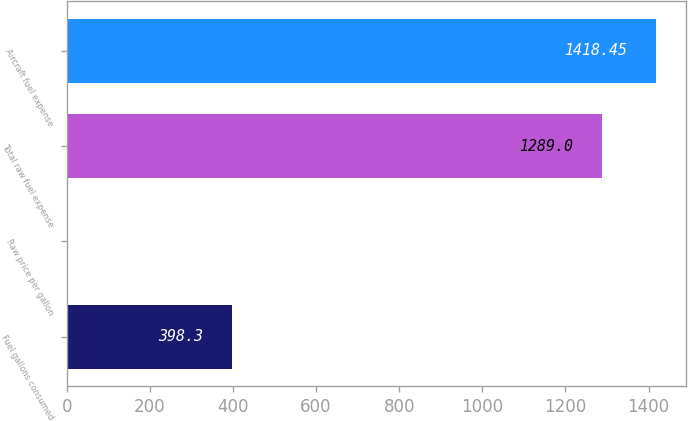<chart> <loc_0><loc_0><loc_500><loc_500><bar_chart><fcel>Fuel gallons consumed<fcel>Raw price per gallon<fcel>Total raw fuel expense<fcel>Aircraft fuel expense<nl><fcel>398.3<fcel>3.24<fcel>1289<fcel>1418.45<nl></chart> 